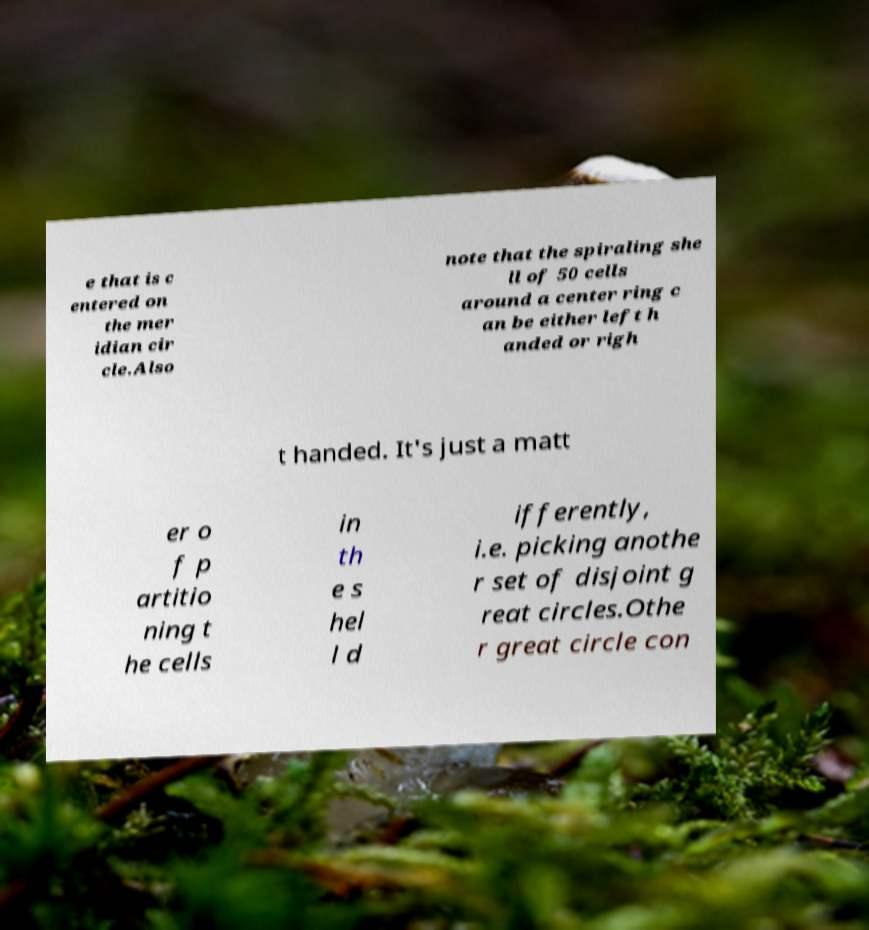Could you extract and type out the text from this image? e that is c entered on the mer idian cir cle.Also note that the spiraling she ll of 50 cells around a center ring c an be either left h anded or righ t handed. It's just a matt er o f p artitio ning t he cells in th e s hel l d ifferently, i.e. picking anothe r set of disjoint g reat circles.Othe r great circle con 